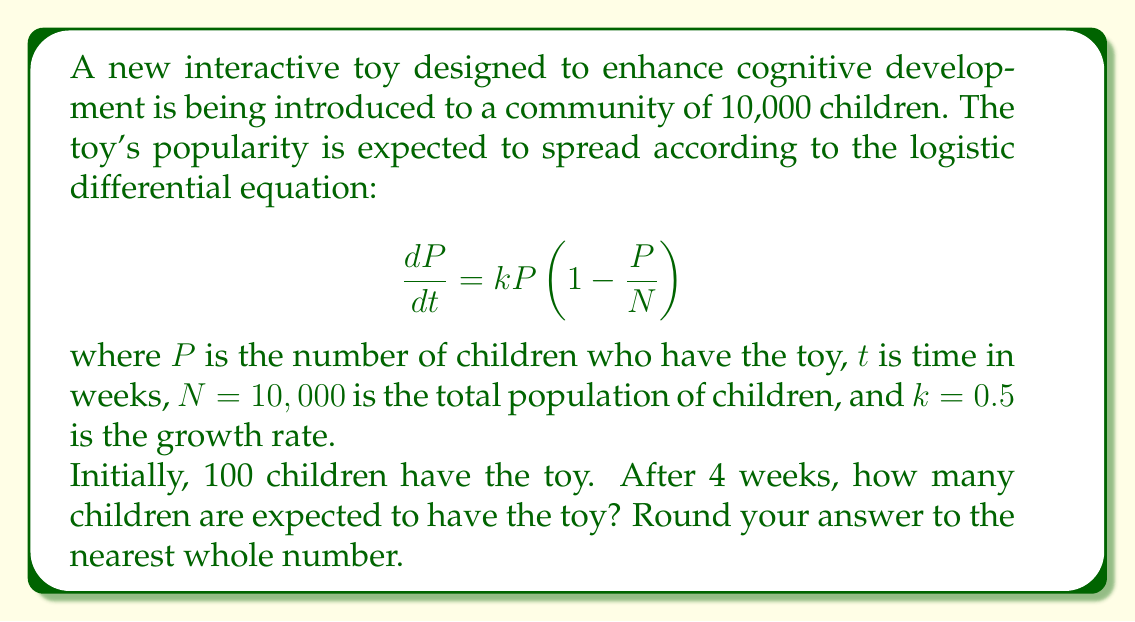Could you help me with this problem? To solve this problem, we need to use the solution to the logistic differential equation:

$$P(t) = \frac{N}{1 + (\frac{N}{P_0} - 1)e^{-kt}}$$

Where:
- $N = 10,000$ (total population)
- $P_0 = 100$ (initial number of children with the toy)
- $k = 0.5$ (growth rate)
- $t = 4$ (time in weeks)

Let's solve this step-by-step:

1) First, let's substitute these values into the equation:

   $$P(4) = \frac{10,000}{1 + (\frac{10,000}{100} - 1)e^{-0.5(4)}}$$

2) Simplify inside the parentheses:

   $$P(4) = \frac{10,000}{1 + (100 - 1)e^{-2}}$$

3) Calculate $e^{-2}$:

   $$e^{-2} \approx 0.1353$$

4) Multiply:

   $$P(4) = \frac{10,000}{1 + (99)(0.1353)} = \frac{10,000}{1 + 13.3947}$$

5) Add in the denominator:

   $$P(4) = \frac{10,000}{14.3947}$$

6) Divide:

   $$P(4) \approx 694.7$$

7) Rounding to the nearest whole number:

   $$P(4) \approx 695$$

Therefore, after 4 weeks, approximately 695 children are expected to have the toy.
Answer: 695 children 